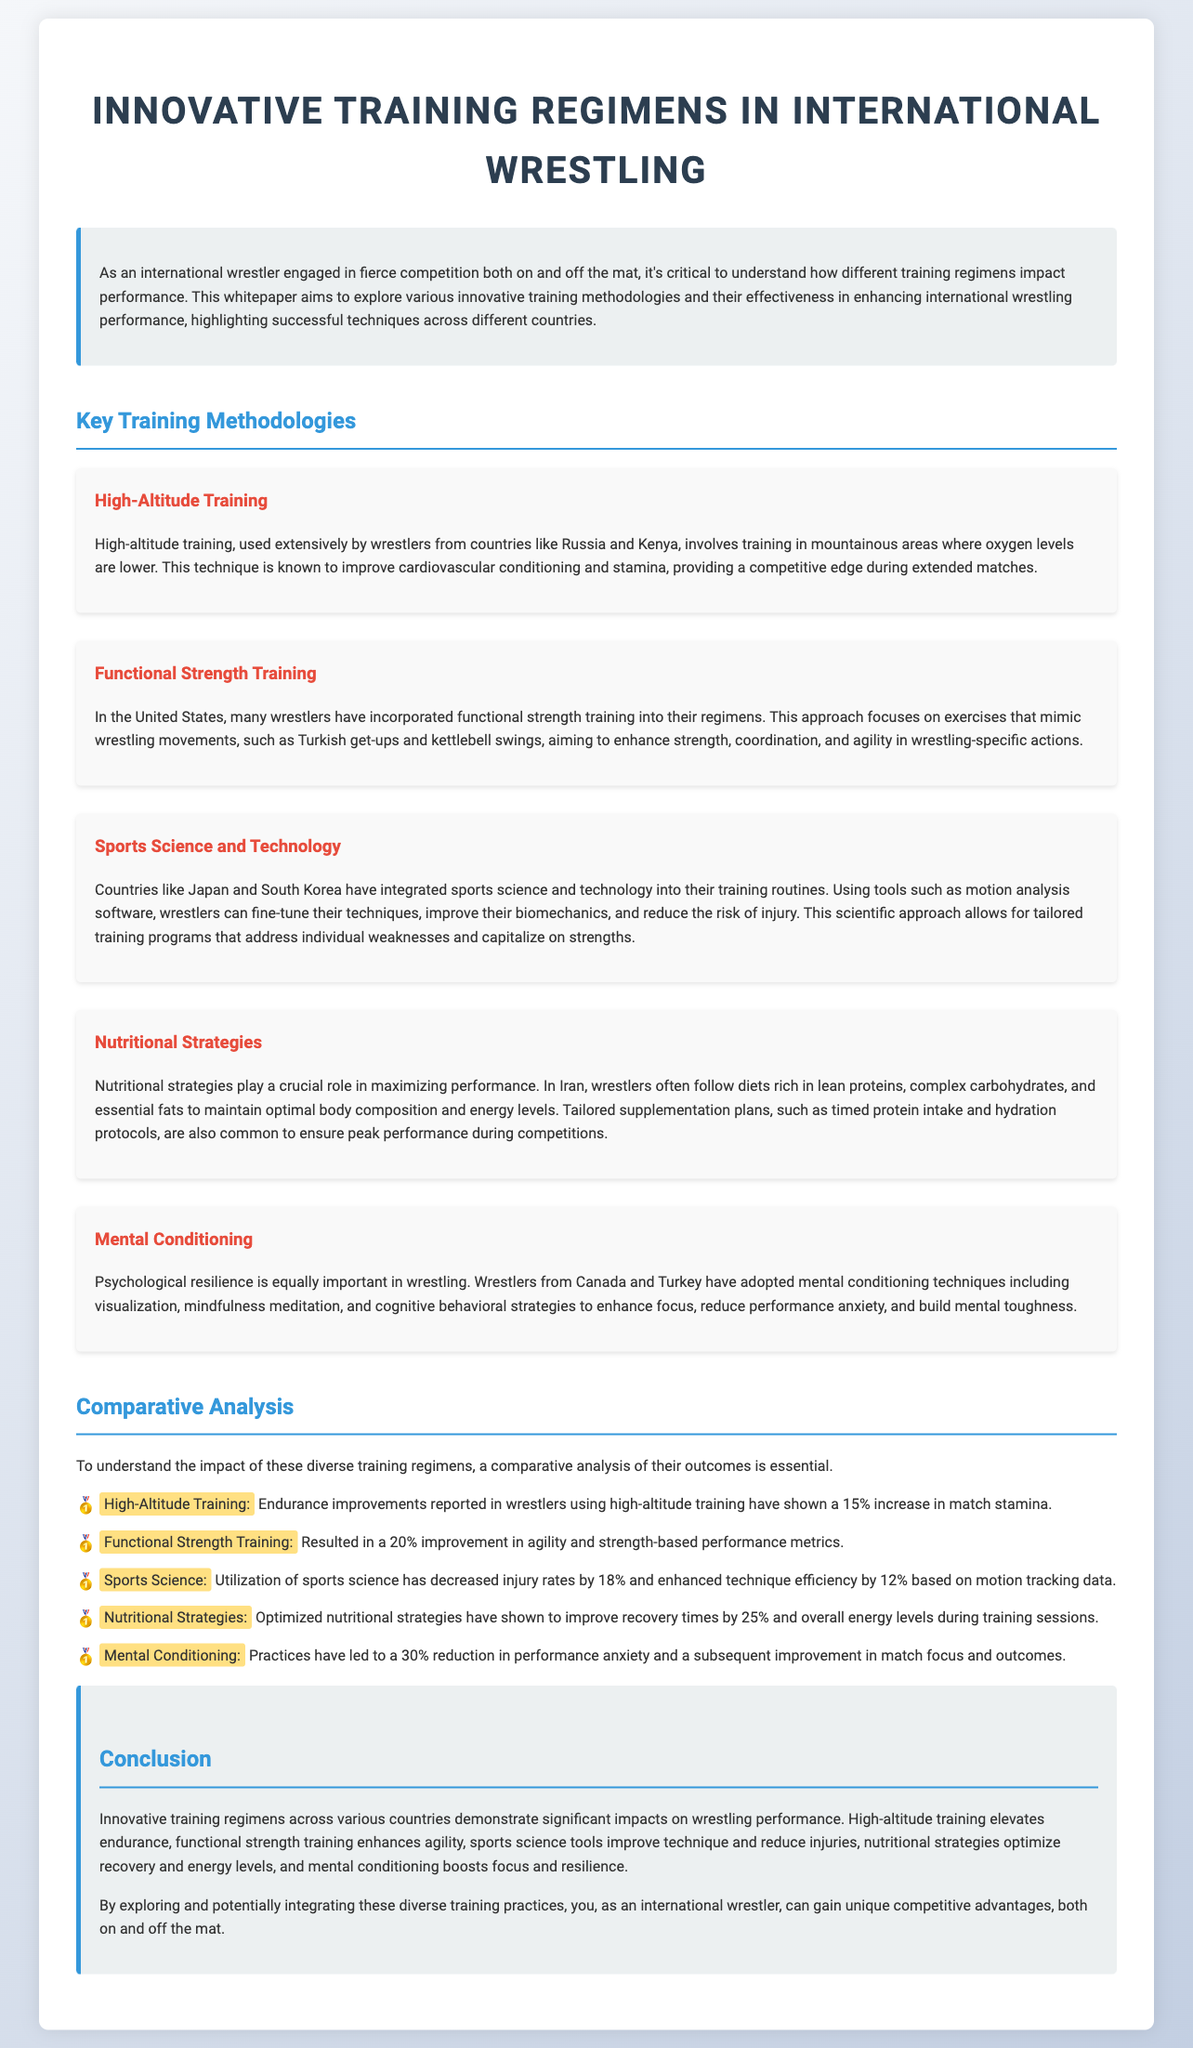What training methodology is used in mountainous areas? The document states that high-altitude training is used extensively by wrestlers in countries like Russia and Kenya.
Answer: high-altitude training Which training regimen improved agility and strength-based performance metrics by 20%? According to the comparative analysis, functional strength training resulted in a 20% improvement in agility and strength-based performance metrics.
Answer: Functional Strength Training What percentage increase in match stamina was reported from high-altitude training? The document indicates that high-altitude training has shown a 15% increase in match stamina.
Answer: 15% Which countries are noted for integrating sports science and technology in their wrestling training? The document highlights Japan and South Korea for their integration of sports science and technology into training routines.
Answer: Japan and South Korea How much did mental conditioning practices reduce performance anxiety? The document states that mental conditioning practices led to a 30% reduction in performance anxiety.
Answer: 30% What is the primary focus of functional strength training? The document describes that functional strength training focuses on exercises that mimic wrestling movements.
Answer: Exercises that mimic wrestling movements What role do nutritional strategies play in wrestling performance? The document notes that nutritional strategies are crucial for maximizing performance and maintaining optimal body composition and energy levels.
Answer: Maximizing performance What type of training is mentioned as significantly improving recovery times by 25%? According to the document, optimized nutritional strategies have shown to improve recovery times by 25%.
Answer: Nutritional Strategies 